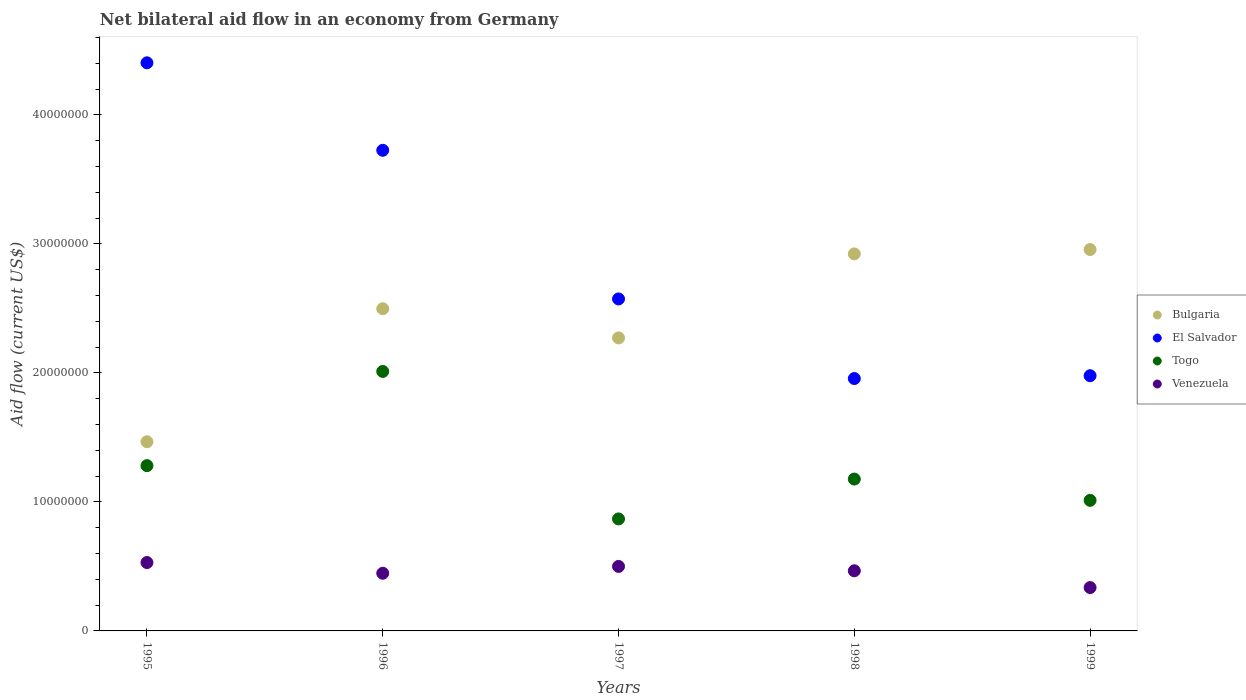Is the number of dotlines equal to the number of legend labels?
Keep it short and to the point. Yes. What is the net bilateral aid flow in El Salvador in 1995?
Provide a short and direct response. 4.40e+07. Across all years, what is the maximum net bilateral aid flow in El Salvador?
Your answer should be very brief. 4.40e+07. Across all years, what is the minimum net bilateral aid flow in El Salvador?
Offer a terse response. 1.96e+07. What is the total net bilateral aid flow in El Salvador in the graph?
Provide a succinct answer. 1.46e+08. What is the difference between the net bilateral aid flow in Venezuela in 1997 and that in 1999?
Provide a succinct answer. 1.64e+06. What is the difference between the net bilateral aid flow in Venezuela in 1998 and the net bilateral aid flow in Bulgaria in 1997?
Your answer should be compact. -1.80e+07. What is the average net bilateral aid flow in Togo per year?
Ensure brevity in your answer.  1.27e+07. In the year 1997, what is the difference between the net bilateral aid flow in El Salvador and net bilateral aid flow in Venezuela?
Offer a terse response. 2.07e+07. What is the ratio of the net bilateral aid flow in Togo in 1995 to that in 1999?
Your answer should be compact. 1.27. Is the net bilateral aid flow in Togo in 1995 less than that in 1996?
Offer a terse response. Yes. What is the difference between the highest and the second highest net bilateral aid flow in El Salvador?
Your response must be concise. 6.78e+06. What is the difference between the highest and the lowest net bilateral aid flow in Venezuela?
Keep it short and to the point. 1.94e+06. In how many years, is the net bilateral aid flow in Bulgaria greater than the average net bilateral aid flow in Bulgaria taken over all years?
Provide a succinct answer. 3. Is the sum of the net bilateral aid flow in Bulgaria in 1996 and 1997 greater than the maximum net bilateral aid flow in Togo across all years?
Your response must be concise. Yes. Is it the case that in every year, the sum of the net bilateral aid flow in El Salvador and net bilateral aid flow in Bulgaria  is greater than the net bilateral aid flow in Togo?
Provide a short and direct response. Yes. Does the net bilateral aid flow in Togo monotonically increase over the years?
Ensure brevity in your answer.  No. How many years are there in the graph?
Provide a short and direct response. 5. Does the graph contain grids?
Your response must be concise. No. Where does the legend appear in the graph?
Give a very brief answer. Center right. How many legend labels are there?
Your response must be concise. 4. How are the legend labels stacked?
Offer a terse response. Vertical. What is the title of the graph?
Make the answer very short. Net bilateral aid flow in an economy from Germany. Does "Lower middle income" appear as one of the legend labels in the graph?
Give a very brief answer. No. What is the label or title of the Y-axis?
Offer a terse response. Aid flow (current US$). What is the Aid flow (current US$) of Bulgaria in 1995?
Offer a terse response. 1.47e+07. What is the Aid flow (current US$) of El Salvador in 1995?
Offer a very short reply. 4.40e+07. What is the Aid flow (current US$) of Togo in 1995?
Keep it short and to the point. 1.28e+07. What is the Aid flow (current US$) of Venezuela in 1995?
Make the answer very short. 5.30e+06. What is the Aid flow (current US$) of Bulgaria in 1996?
Your answer should be compact. 2.50e+07. What is the Aid flow (current US$) in El Salvador in 1996?
Keep it short and to the point. 3.72e+07. What is the Aid flow (current US$) in Togo in 1996?
Make the answer very short. 2.01e+07. What is the Aid flow (current US$) in Venezuela in 1996?
Keep it short and to the point. 4.47e+06. What is the Aid flow (current US$) of Bulgaria in 1997?
Give a very brief answer. 2.27e+07. What is the Aid flow (current US$) in El Salvador in 1997?
Provide a short and direct response. 2.57e+07. What is the Aid flow (current US$) in Togo in 1997?
Your answer should be compact. 8.68e+06. What is the Aid flow (current US$) of Venezuela in 1997?
Your answer should be very brief. 5.00e+06. What is the Aid flow (current US$) of Bulgaria in 1998?
Your response must be concise. 2.92e+07. What is the Aid flow (current US$) of El Salvador in 1998?
Offer a very short reply. 1.96e+07. What is the Aid flow (current US$) in Togo in 1998?
Your answer should be very brief. 1.18e+07. What is the Aid flow (current US$) of Venezuela in 1998?
Provide a succinct answer. 4.66e+06. What is the Aid flow (current US$) of Bulgaria in 1999?
Keep it short and to the point. 2.96e+07. What is the Aid flow (current US$) of El Salvador in 1999?
Provide a short and direct response. 1.98e+07. What is the Aid flow (current US$) of Togo in 1999?
Give a very brief answer. 1.01e+07. What is the Aid flow (current US$) of Venezuela in 1999?
Offer a very short reply. 3.36e+06. Across all years, what is the maximum Aid flow (current US$) of Bulgaria?
Provide a short and direct response. 2.96e+07. Across all years, what is the maximum Aid flow (current US$) of El Salvador?
Your answer should be compact. 4.40e+07. Across all years, what is the maximum Aid flow (current US$) of Togo?
Offer a very short reply. 2.01e+07. Across all years, what is the maximum Aid flow (current US$) in Venezuela?
Ensure brevity in your answer.  5.30e+06. Across all years, what is the minimum Aid flow (current US$) in Bulgaria?
Keep it short and to the point. 1.47e+07. Across all years, what is the minimum Aid flow (current US$) of El Salvador?
Offer a very short reply. 1.96e+07. Across all years, what is the minimum Aid flow (current US$) of Togo?
Ensure brevity in your answer.  8.68e+06. Across all years, what is the minimum Aid flow (current US$) in Venezuela?
Offer a very short reply. 3.36e+06. What is the total Aid flow (current US$) in Bulgaria in the graph?
Give a very brief answer. 1.21e+08. What is the total Aid flow (current US$) of El Salvador in the graph?
Give a very brief answer. 1.46e+08. What is the total Aid flow (current US$) of Togo in the graph?
Keep it short and to the point. 6.35e+07. What is the total Aid flow (current US$) of Venezuela in the graph?
Your response must be concise. 2.28e+07. What is the difference between the Aid flow (current US$) in Bulgaria in 1995 and that in 1996?
Ensure brevity in your answer.  -1.03e+07. What is the difference between the Aid flow (current US$) of El Salvador in 1995 and that in 1996?
Provide a short and direct response. 6.78e+06. What is the difference between the Aid flow (current US$) of Togo in 1995 and that in 1996?
Ensure brevity in your answer.  -7.30e+06. What is the difference between the Aid flow (current US$) in Venezuela in 1995 and that in 1996?
Keep it short and to the point. 8.30e+05. What is the difference between the Aid flow (current US$) in Bulgaria in 1995 and that in 1997?
Provide a succinct answer. -8.05e+06. What is the difference between the Aid flow (current US$) of El Salvador in 1995 and that in 1997?
Ensure brevity in your answer.  1.83e+07. What is the difference between the Aid flow (current US$) of Togo in 1995 and that in 1997?
Offer a very short reply. 4.13e+06. What is the difference between the Aid flow (current US$) in Bulgaria in 1995 and that in 1998?
Offer a terse response. -1.46e+07. What is the difference between the Aid flow (current US$) of El Salvador in 1995 and that in 1998?
Offer a very short reply. 2.45e+07. What is the difference between the Aid flow (current US$) of Togo in 1995 and that in 1998?
Provide a succinct answer. 1.04e+06. What is the difference between the Aid flow (current US$) in Venezuela in 1995 and that in 1998?
Provide a succinct answer. 6.40e+05. What is the difference between the Aid flow (current US$) in Bulgaria in 1995 and that in 1999?
Ensure brevity in your answer.  -1.49e+07. What is the difference between the Aid flow (current US$) of El Salvador in 1995 and that in 1999?
Keep it short and to the point. 2.42e+07. What is the difference between the Aid flow (current US$) of Togo in 1995 and that in 1999?
Ensure brevity in your answer.  2.69e+06. What is the difference between the Aid flow (current US$) of Venezuela in 1995 and that in 1999?
Your answer should be very brief. 1.94e+06. What is the difference between the Aid flow (current US$) of Bulgaria in 1996 and that in 1997?
Give a very brief answer. 2.26e+06. What is the difference between the Aid flow (current US$) of El Salvador in 1996 and that in 1997?
Offer a terse response. 1.15e+07. What is the difference between the Aid flow (current US$) in Togo in 1996 and that in 1997?
Make the answer very short. 1.14e+07. What is the difference between the Aid flow (current US$) in Venezuela in 1996 and that in 1997?
Provide a succinct answer. -5.30e+05. What is the difference between the Aid flow (current US$) in Bulgaria in 1996 and that in 1998?
Offer a very short reply. -4.25e+06. What is the difference between the Aid flow (current US$) in El Salvador in 1996 and that in 1998?
Offer a very short reply. 1.77e+07. What is the difference between the Aid flow (current US$) of Togo in 1996 and that in 1998?
Your response must be concise. 8.34e+06. What is the difference between the Aid flow (current US$) in Venezuela in 1996 and that in 1998?
Offer a terse response. -1.90e+05. What is the difference between the Aid flow (current US$) in Bulgaria in 1996 and that in 1999?
Your response must be concise. -4.59e+06. What is the difference between the Aid flow (current US$) of El Salvador in 1996 and that in 1999?
Give a very brief answer. 1.75e+07. What is the difference between the Aid flow (current US$) in Togo in 1996 and that in 1999?
Ensure brevity in your answer.  9.99e+06. What is the difference between the Aid flow (current US$) in Venezuela in 1996 and that in 1999?
Keep it short and to the point. 1.11e+06. What is the difference between the Aid flow (current US$) of Bulgaria in 1997 and that in 1998?
Ensure brevity in your answer.  -6.51e+06. What is the difference between the Aid flow (current US$) of El Salvador in 1997 and that in 1998?
Make the answer very short. 6.17e+06. What is the difference between the Aid flow (current US$) in Togo in 1997 and that in 1998?
Ensure brevity in your answer.  -3.09e+06. What is the difference between the Aid flow (current US$) of Bulgaria in 1997 and that in 1999?
Make the answer very short. -6.85e+06. What is the difference between the Aid flow (current US$) of El Salvador in 1997 and that in 1999?
Your answer should be compact. 5.95e+06. What is the difference between the Aid flow (current US$) in Togo in 1997 and that in 1999?
Your answer should be very brief. -1.44e+06. What is the difference between the Aid flow (current US$) in Venezuela in 1997 and that in 1999?
Offer a very short reply. 1.64e+06. What is the difference between the Aid flow (current US$) of Togo in 1998 and that in 1999?
Your answer should be very brief. 1.65e+06. What is the difference between the Aid flow (current US$) of Venezuela in 1998 and that in 1999?
Provide a succinct answer. 1.30e+06. What is the difference between the Aid flow (current US$) of Bulgaria in 1995 and the Aid flow (current US$) of El Salvador in 1996?
Provide a short and direct response. -2.26e+07. What is the difference between the Aid flow (current US$) in Bulgaria in 1995 and the Aid flow (current US$) in Togo in 1996?
Your answer should be compact. -5.45e+06. What is the difference between the Aid flow (current US$) of Bulgaria in 1995 and the Aid flow (current US$) of Venezuela in 1996?
Make the answer very short. 1.02e+07. What is the difference between the Aid flow (current US$) in El Salvador in 1995 and the Aid flow (current US$) in Togo in 1996?
Offer a terse response. 2.39e+07. What is the difference between the Aid flow (current US$) of El Salvador in 1995 and the Aid flow (current US$) of Venezuela in 1996?
Keep it short and to the point. 3.96e+07. What is the difference between the Aid flow (current US$) in Togo in 1995 and the Aid flow (current US$) in Venezuela in 1996?
Your answer should be compact. 8.34e+06. What is the difference between the Aid flow (current US$) in Bulgaria in 1995 and the Aid flow (current US$) in El Salvador in 1997?
Your answer should be compact. -1.11e+07. What is the difference between the Aid flow (current US$) in Bulgaria in 1995 and the Aid flow (current US$) in Togo in 1997?
Give a very brief answer. 5.98e+06. What is the difference between the Aid flow (current US$) of Bulgaria in 1995 and the Aid flow (current US$) of Venezuela in 1997?
Provide a short and direct response. 9.66e+06. What is the difference between the Aid flow (current US$) of El Salvador in 1995 and the Aid flow (current US$) of Togo in 1997?
Ensure brevity in your answer.  3.54e+07. What is the difference between the Aid flow (current US$) of El Salvador in 1995 and the Aid flow (current US$) of Venezuela in 1997?
Your response must be concise. 3.90e+07. What is the difference between the Aid flow (current US$) of Togo in 1995 and the Aid flow (current US$) of Venezuela in 1997?
Provide a succinct answer. 7.81e+06. What is the difference between the Aid flow (current US$) in Bulgaria in 1995 and the Aid flow (current US$) in El Salvador in 1998?
Give a very brief answer. -4.90e+06. What is the difference between the Aid flow (current US$) of Bulgaria in 1995 and the Aid flow (current US$) of Togo in 1998?
Your answer should be compact. 2.89e+06. What is the difference between the Aid flow (current US$) of El Salvador in 1995 and the Aid flow (current US$) of Togo in 1998?
Your response must be concise. 3.23e+07. What is the difference between the Aid flow (current US$) of El Salvador in 1995 and the Aid flow (current US$) of Venezuela in 1998?
Keep it short and to the point. 3.94e+07. What is the difference between the Aid flow (current US$) in Togo in 1995 and the Aid flow (current US$) in Venezuela in 1998?
Offer a terse response. 8.15e+06. What is the difference between the Aid flow (current US$) in Bulgaria in 1995 and the Aid flow (current US$) in El Salvador in 1999?
Give a very brief answer. -5.12e+06. What is the difference between the Aid flow (current US$) of Bulgaria in 1995 and the Aid flow (current US$) of Togo in 1999?
Give a very brief answer. 4.54e+06. What is the difference between the Aid flow (current US$) in Bulgaria in 1995 and the Aid flow (current US$) in Venezuela in 1999?
Offer a terse response. 1.13e+07. What is the difference between the Aid flow (current US$) in El Salvador in 1995 and the Aid flow (current US$) in Togo in 1999?
Give a very brief answer. 3.39e+07. What is the difference between the Aid flow (current US$) in El Salvador in 1995 and the Aid flow (current US$) in Venezuela in 1999?
Offer a terse response. 4.07e+07. What is the difference between the Aid flow (current US$) in Togo in 1995 and the Aid flow (current US$) in Venezuela in 1999?
Offer a very short reply. 9.45e+06. What is the difference between the Aid flow (current US$) of Bulgaria in 1996 and the Aid flow (current US$) of El Salvador in 1997?
Provide a short and direct response. -7.60e+05. What is the difference between the Aid flow (current US$) of Bulgaria in 1996 and the Aid flow (current US$) of Togo in 1997?
Your answer should be very brief. 1.63e+07. What is the difference between the Aid flow (current US$) of Bulgaria in 1996 and the Aid flow (current US$) of Venezuela in 1997?
Give a very brief answer. 2.00e+07. What is the difference between the Aid flow (current US$) of El Salvador in 1996 and the Aid flow (current US$) of Togo in 1997?
Provide a succinct answer. 2.86e+07. What is the difference between the Aid flow (current US$) of El Salvador in 1996 and the Aid flow (current US$) of Venezuela in 1997?
Provide a succinct answer. 3.22e+07. What is the difference between the Aid flow (current US$) in Togo in 1996 and the Aid flow (current US$) in Venezuela in 1997?
Provide a short and direct response. 1.51e+07. What is the difference between the Aid flow (current US$) in Bulgaria in 1996 and the Aid flow (current US$) in El Salvador in 1998?
Make the answer very short. 5.41e+06. What is the difference between the Aid flow (current US$) of Bulgaria in 1996 and the Aid flow (current US$) of Togo in 1998?
Make the answer very short. 1.32e+07. What is the difference between the Aid flow (current US$) of Bulgaria in 1996 and the Aid flow (current US$) of Venezuela in 1998?
Keep it short and to the point. 2.03e+07. What is the difference between the Aid flow (current US$) in El Salvador in 1996 and the Aid flow (current US$) in Togo in 1998?
Make the answer very short. 2.55e+07. What is the difference between the Aid flow (current US$) of El Salvador in 1996 and the Aid flow (current US$) of Venezuela in 1998?
Offer a very short reply. 3.26e+07. What is the difference between the Aid flow (current US$) of Togo in 1996 and the Aid flow (current US$) of Venezuela in 1998?
Your response must be concise. 1.54e+07. What is the difference between the Aid flow (current US$) of Bulgaria in 1996 and the Aid flow (current US$) of El Salvador in 1999?
Offer a terse response. 5.19e+06. What is the difference between the Aid flow (current US$) of Bulgaria in 1996 and the Aid flow (current US$) of Togo in 1999?
Ensure brevity in your answer.  1.48e+07. What is the difference between the Aid flow (current US$) of Bulgaria in 1996 and the Aid flow (current US$) of Venezuela in 1999?
Give a very brief answer. 2.16e+07. What is the difference between the Aid flow (current US$) in El Salvador in 1996 and the Aid flow (current US$) in Togo in 1999?
Ensure brevity in your answer.  2.71e+07. What is the difference between the Aid flow (current US$) in El Salvador in 1996 and the Aid flow (current US$) in Venezuela in 1999?
Keep it short and to the point. 3.39e+07. What is the difference between the Aid flow (current US$) in Togo in 1996 and the Aid flow (current US$) in Venezuela in 1999?
Make the answer very short. 1.68e+07. What is the difference between the Aid flow (current US$) in Bulgaria in 1997 and the Aid flow (current US$) in El Salvador in 1998?
Your answer should be compact. 3.15e+06. What is the difference between the Aid flow (current US$) of Bulgaria in 1997 and the Aid flow (current US$) of Togo in 1998?
Make the answer very short. 1.09e+07. What is the difference between the Aid flow (current US$) in Bulgaria in 1997 and the Aid flow (current US$) in Venezuela in 1998?
Provide a short and direct response. 1.80e+07. What is the difference between the Aid flow (current US$) of El Salvador in 1997 and the Aid flow (current US$) of Togo in 1998?
Offer a terse response. 1.40e+07. What is the difference between the Aid flow (current US$) of El Salvador in 1997 and the Aid flow (current US$) of Venezuela in 1998?
Your response must be concise. 2.11e+07. What is the difference between the Aid flow (current US$) in Togo in 1997 and the Aid flow (current US$) in Venezuela in 1998?
Offer a very short reply. 4.02e+06. What is the difference between the Aid flow (current US$) in Bulgaria in 1997 and the Aid flow (current US$) in El Salvador in 1999?
Your response must be concise. 2.93e+06. What is the difference between the Aid flow (current US$) in Bulgaria in 1997 and the Aid flow (current US$) in Togo in 1999?
Ensure brevity in your answer.  1.26e+07. What is the difference between the Aid flow (current US$) of Bulgaria in 1997 and the Aid flow (current US$) of Venezuela in 1999?
Provide a short and direct response. 1.94e+07. What is the difference between the Aid flow (current US$) in El Salvador in 1997 and the Aid flow (current US$) in Togo in 1999?
Offer a terse response. 1.56e+07. What is the difference between the Aid flow (current US$) of El Salvador in 1997 and the Aid flow (current US$) of Venezuela in 1999?
Your answer should be compact. 2.24e+07. What is the difference between the Aid flow (current US$) of Togo in 1997 and the Aid flow (current US$) of Venezuela in 1999?
Provide a short and direct response. 5.32e+06. What is the difference between the Aid flow (current US$) of Bulgaria in 1998 and the Aid flow (current US$) of El Salvador in 1999?
Your answer should be very brief. 9.44e+06. What is the difference between the Aid flow (current US$) in Bulgaria in 1998 and the Aid flow (current US$) in Togo in 1999?
Your answer should be very brief. 1.91e+07. What is the difference between the Aid flow (current US$) of Bulgaria in 1998 and the Aid flow (current US$) of Venezuela in 1999?
Make the answer very short. 2.59e+07. What is the difference between the Aid flow (current US$) of El Salvador in 1998 and the Aid flow (current US$) of Togo in 1999?
Ensure brevity in your answer.  9.44e+06. What is the difference between the Aid flow (current US$) of El Salvador in 1998 and the Aid flow (current US$) of Venezuela in 1999?
Keep it short and to the point. 1.62e+07. What is the difference between the Aid flow (current US$) in Togo in 1998 and the Aid flow (current US$) in Venezuela in 1999?
Provide a succinct answer. 8.41e+06. What is the average Aid flow (current US$) of Bulgaria per year?
Your answer should be compact. 2.42e+07. What is the average Aid flow (current US$) in El Salvador per year?
Provide a short and direct response. 2.93e+07. What is the average Aid flow (current US$) of Togo per year?
Keep it short and to the point. 1.27e+07. What is the average Aid flow (current US$) in Venezuela per year?
Provide a succinct answer. 4.56e+06. In the year 1995, what is the difference between the Aid flow (current US$) in Bulgaria and Aid flow (current US$) in El Salvador?
Provide a succinct answer. -2.94e+07. In the year 1995, what is the difference between the Aid flow (current US$) in Bulgaria and Aid flow (current US$) in Togo?
Provide a succinct answer. 1.85e+06. In the year 1995, what is the difference between the Aid flow (current US$) in Bulgaria and Aid flow (current US$) in Venezuela?
Make the answer very short. 9.36e+06. In the year 1995, what is the difference between the Aid flow (current US$) in El Salvador and Aid flow (current US$) in Togo?
Offer a very short reply. 3.12e+07. In the year 1995, what is the difference between the Aid flow (current US$) of El Salvador and Aid flow (current US$) of Venezuela?
Make the answer very short. 3.87e+07. In the year 1995, what is the difference between the Aid flow (current US$) in Togo and Aid flow (current US$) in Venezuela?
Offer a terse response. 7.51e+06. In the year 1996, what is the difference between the Aid flow (current US$) of Bulgaria and Aid flow (current US$) of El Salvador?
Make the answer very short. -1.23e+07. In the year 1996, what is the difference between the Aid flow (current US$) in Bulgaria and Aid flow (current US$) in Togo?
Offer a very short reply. 4.86e+06. In the year 1996, what is the difference between the Aid flow (current US$) in Bulgaria and Aid flow (current US$) in Venezuela?
Give a very brief answer. 2.05e+07. In the year 1996, what is the difference between the Aid flow (current US$) in El Salvador and Aid flow (current US$) in Togo?
Make the answer very short. 1.71e+07. In the year 1996, what is the difference between the Aid flow (current US$) in El Salvador and Aid flow (current US$) in Venezuela?
Give a very brief answer. 3.28e+07. In the year 1996, what is the difference between the Aid flow (current US$) of Togo and Aid flow (current US$) of Venezuela?
Provide a succinct answer. 1.56e+07. In the year 1997, what is the difference between the Aid flow (current US$) of Bulgaria and Aid flow (current US$) of El Salvador?
Your answer should be very brief. -3.02e+06. In the year 1997, what is the difference between the Aid flow (current US$) of Bulgaria and Aid flow (current US$) of Togo?
Your response must be concise. 1.40e+07. In the year 1997, what is the difference between the Aid flow (current US$) in Bulgaria and Aid flow (current US$) in Venezuela?
Ensure brevity in your answer.  1.77e+07. In the year 1997, what is the difference between the Aid flow (current US$) of El Salvador and Aid flow (current US$) of Togo?
Your answer should be very brief. 1.70e+07. In the year 1997, what is the difference between the Aid flow (current US$) of El Salvador and Aid flow (current US$) of Venezuela?
Offer a terse response. 2.07e+07. In the year 1997, what is the difference between the Aid flow (current US$) of Togo and Aid flow (current US$) of Venezuela?
Keep it short and to the point. 3.68e+06. In the year 1998, what is the difference between the Aid flow (current US$) in Bulgaria and Aid flow (current US$) in El Salvador?
Offer a terse response. 9.66e+06. In the year 1998, what is the difference between the Aid flow (current US$) of Bulgaria and Aid flow (current US$) of Togo?
Give a very brief answer. 1.74e+07. In the year 1998, what is the difference between the Aid flow (current US$) in Bulgaria and Aid flow (current US$) in Venezuela?
Offer a very short reply. 2.46e+07. In the year 1998, what is the difference between the Aid flow (current US$) in El Salvador and Aid flow (current US$) in Togo?
Provide a short and direct response. 7.79e+06. In the year 1998, what is the difference between the Aid flow (current US$) in El Salvador and Aid flow (current US$) in Venezuela?
Make the answer very short. 1.49e+07. In the year 1998, what is the difference between the Aid flow (current US$) in Togo and Aid flow (current US$) in Venezuela?
Give a very brief answer. 7.11e+06. In the year 1999, what is the difference between the Aid flow (current US$) in Bulgaria and Aid flow (current US$) in El Salvador?
Give a very brief answer. 9.78e+06. In the year 1999, what is the difference between the Aid flow (current US$) of Bulgaria and Aid flow (current US$) of Togo?
Keep it short and to the point. 1.94e+07. In the year 1999, what is the difference between the Aid flow (current US$) in Bulgaria and Aid flow (current US$) in Venezuela?
Offer a very short reply. 2.62e+07. In the year 1999, what is the difference between the Aid flow (current US$) in El Salvador and Aid flow (current US$) in Togo?
Offer a terse response. 9.66e+06. In the year 1999, what is the difference between the Aid flow (current US$) in El Salvador and Aid flow (current US$) in Venezuela?
Your answer should be very brief. 1.64e+07. In the year 1999, what is the difference between the Aid flow (current US$) in Togo and Aid flow (current US$) in Venezuela?
Keep it short and to the point. 6.76e+06. What is the ratio of the Aid flow (current US$) in Bulgaria in 1995 to that in 1996?
Make the answer very short. 0.59. What is the ratio of the Aid flow (current US$) of El Salvador in 1995 to that in 1996?
Provide a succinct answer. 1.18. What is the ratio of the Aid flow (current US$) of Togo in 1995 to that in 1996?
Offer a terse response. 0.64. What is the ratio of the Aid flow (current US$) in Venezuela in 1995 to that in 1996?
Give a very brief answer. 1.19. What is the ratio of the Aid flow (current US$) of Bulgaria in 1995 to that in 1997?
Offer a terse response. 0.65. What is the ratio of the Aid flow (current US$) in El Salvador in 1995 to that in 1997?
Your response must be concise. 1.71. What is the ratio of the Aid flow (current US$) of Togo in 1995 to that in 1997?
Offer a terse response. 1.48. What is the ratio of the Aid flow (current US$) in Venezuela in 1995 to that in 1997?
Offer a terse response. 1.06. What is the ratio of the Aid flow (current US$) in Bulgaria in 1995 to that in 1998?
Keep it short and to the point. 0.5. What is the ratio of the Aid flow (current US$) in El Salvador in 1995 to that in 1998?
Your answer should be compact. 2.25. What is the ratio of the Aid flow (current US$) of Togo in 1995 to that in 1998?
Your response must be concise. 1.09. What is the ratio of the Aid flow (current US$) in Venezuela in 1995 to that in 1998?
Ensure brevity in your answer.  1.14. What is the ratio of the Aid flow (current US$) in Bulgaria in 1995 to that in 1999?
Your response must be concise. 0.5. What is the ratio of the Aid flow (current US$) of El Salvador in 1995 to that in 1999?
Offer a terse response. 2.23. What is the ratio of the Aid flow (current US$) in Togo in 1995 to that in 1999?
Make the answer very short. 1.27. What is the ratio of the Aid flow (current US$) in Venezuela in 1995 to that in 1999?
Your response must be concise. 1.58. What is the ratio of the Aid flow (current US$) in Bulgaria in 1996 to that in 1997?
Your answer should be compact. 1.1. What is the ratio of the Aid flow (current US$) of El Salvador in 1996 to that in 1997?
Provide a succinct answer. 1.45. What is the ratio of the Aid flow (current US$) of Togo in 1996 to that in 1997?
Provide a succinct answer. 2.32. What is the ratio of the Aid flow (current US$) of Venezuela in 1996 to that in 1997?
Provide a succinct answer. 0.89. What is the ratio of the Aid flow (current US$) in Bulgaria in 1996 to that in 1998?
Your answer should be compact. 0.85. What is the ratio of the Aid flow (current US$) in El Salvador in 1996 to that in 1998?
Offer a very short reply. 1.9. What is the ratio of the Aid flow (current US$) in Togo in 1996 to that in 1998?
Offer a very short reply. 1.71. What is the ratio of the Aid flow (current US$) in Venezuela in 1996 to that in 1998?
Provide a succinct answer. 0.96. What is the ratio of the Aid flow (current US$) in Bulgaria in 1996 to that in 1999?
Your answer should be very brief. 0.84. What is the ratio of the Aid flow (current US$) in El Salvador in 1996 to that in 1999?
Give a very brief answer. 1.88. What is the ratio of the Aid flow (current US$) of Togo in 1996 to that in 1999?
Offer a very short reply. 1.99. What is the ratio of the Aid flow (current US$) in Venezuela in 1996 to that in 1999?
Provide a succinct answer. 1.33. What is the ratio of the Aid flow (current US$) in Bulgaria in 1997 to that in 1998?
Your answer should be compact. 0.78. What is the ratio of the Aid flow (current US$) in El Salvador in 1997 to that in 1998?
Give a very brief answer. 1.32. What is the ratio of the Aid flow (current US$) in Togo in 1997 to that in 1998?
Your response must be concise. 0.74. What is the ratio of the Aid flow (current US$) in Venezuela in 1997 to that in 1998?
Ensure brevity in your answer.  1.07. What is the ratio of the Aid flow (current US$) of Bulgaria in 1997 to that in 1999?
Give a very brief answer. 0.77. What is the ratio of the Aid flow (current US$) of El Salvador in 1997 to that in 1999?
Provide a succinct answer. 1.3. What is the ratio of the Aid flow (current US$) in Togo in 1997 to that in 1999?
Provide a short and direct response. 0.86. What is the ratio of the Aid flow (current US$) of Venezuela in 1997 to that in 1999?
Your response must be concise. 1.49. What is the ratio of the Aid flow (current US$) of El Salvador in 1998 to that in 1999?
Keep it short and to the point. 0.99. What is the ratio of the Aid flow (current US$) of Togo in 1998 to that in 1999?
Keep it short and to the point. 1.16. What is the ratio of the Aid flow (current US$) of Venezuela in 1998 to that in 1999?
Your answer should be compact. 1.39. What is the difference between the highest and the second highest Aid flow (current US$) of Bulgaria?
Ensure brevity in your answer.  3.40e+05. What is the difference between the highest and the second highest Aid flow (current US$) in El Salvador?
Make the answer very short. 6.78e+06. What is the difference between the highest and the second highest Aid flow (current US$) of Togo?
Keep it short and to the point. 7.30e+06. What is the difference between the highest and the lowest Aid flow (current US$) of Bulgaria?
Make the answer very short. 1.49e+07. What is the difference between the highest and the lowest Aid flow (current US$) of El Salvador?
Offer a terse response. 2.45e+07. What is the difference between the highest and the lowest Aid flow (current US$) in Togo?
Your response must be concise. 1.14e+07. What is the difference between the highest and the lowest Aid flow (current US$) in Venezuela?
Your answer should be very brief. 1.94e+06. 